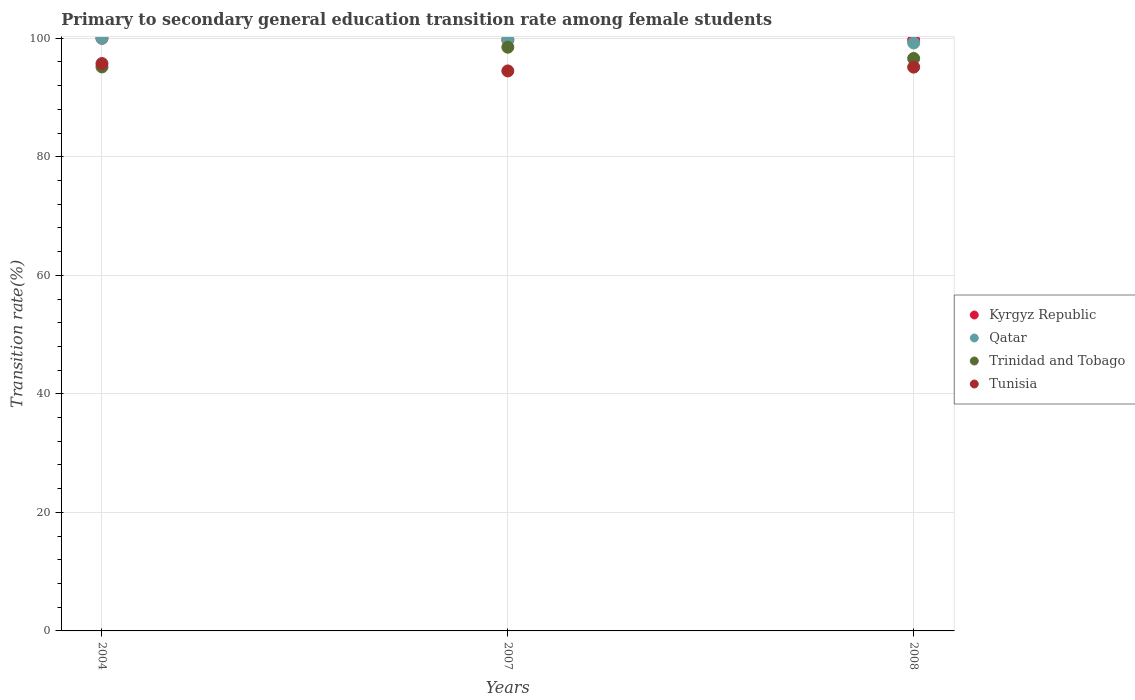How many different coloured dotlines are there?
Your answer should be very brief. 4. What is the transition rate in Kyrgyz Republic in 2008?
Make the answer very short. 99.67. Across all years, what is the minimum transition rate in Trinidad and Tobago?
Keep it short and to the point. 95.15. In which year was the transition rate in Trinidad and Tobago maximum?
Offer a terse response. 2007. In which year was the transition rate in Qatar minimum?
Your response must be concise. 2008. What is the total transition rate in Tunisia in the graph?
Your answer should be compact. 285.33. What is the difference between the transition rate in Kyrgyz Republic in 2007 and that in 2008?
Your response must be concise. 0.04. What is the difference between the transition rate in Kyrgyz Republic in 2004 and the transition rate in Trinidad and Tobago in 2008?
Offer a very short reply. 3.42. What is the average transition rate in Qatar per year?
Ensure brevity in your answer.  99.66. In the year 2007, what is the difference between the transition rate in Trinidad and Tobago and transition rate in Tunisia?
Offer a terse response. 4.01. What is the ratio of the transition rate in Tunisia in 2004 to that in 2007?
Your response must be concise. 1.01. Is the transition rate in Trinidad and Tobago in 2004 less than that in 2007?
Ensure brevity in your answer.  Yes. Is the difference between the transition rate in Trinidad and Tobago in 2004 and 2007 greater than the difference between the transition rate in Tunisia in 2004 and 2007?
Your response must be concise. No. What is the difference between the highest and the second highest transition rate in Tunisia?
Offer a terse response. 0.6. What is the difference between the highest and the lowest transition rate in Kyrgyz Republic?
Your response must be concise. 0.33. Is the sum of the transition rate in Kyrgyz Republic in 2004 and 2007 greater than the maximum transition rate in Trinidad and Tobago across all years?
Ensure brevity in your answer.  Yes. Is it the case that in every year, the sum of the transition rate in Kyrgyz Republic and transition rate in Trinidad and Tobago  is greater than the sum of transition rate in Qatar and transition rate in Tunisia?
Your answer should be compact. Yes. Does the transition rate in Tunisia monotonically increase over the years?
Keep it short and to the point. No. How many years are there in the graph?
Offer a very short reply. 3. What is the difference between two consecutive major ticks on the Y-axis?
Give a very brief answer. 20. Are the values on the major ticks of Y-axis written in scientific E-notation?
Give a very brief answer. No. Where does the legend appear in the graph?
Offer a very short reply. Center right. How many legend labels are there?
Make the answer very short. 4. How are the legend labels stacked?
Ensure brevity in your answer.  Vertical. What is the title of the graph?
Ensure brevity in your answer.  Primary to secondary general education transition rate among female students. What is the label or title of the Y-axis?
Keep it short and to the point. Transition rate(%). What is the Transition rate(%) of Kyrgyz Republic in 2004?
Offer a very short reply. 100. What is the Transition rate(%) of Qatar in 2004?
Your response must be concise. 100. What is the Transition rate(%) of Trinidad and Tobago in 2004?
Provide a short and direct response. 95.15. What is the Transition rate(%) in Tunisia in 2004?
Offer a very short reply. 95.72. What is the Transition rate(%) of Kyrgyz Republic in 2007?
Provide a succinct answer. 99.7. What is the Transition rate(%) in Qatar in 2007?
Your answer should be compact. 99.78. What is the Transition rate(%) of Trinidad and Tobago in 2007?
Offer a very short reply. 98.48. What is the Transition rate(%) in Tunisia in 2007?
Make the answer very short. 94.48. What is the Transition rate(%) of Kyrgyz Republic in 2008?
Offer a terse response. 99.67. What is the Transition rate(%) of Qatar in 2008?
Ensure brevity in your answer.  99.2. What is the Transition rate(%) in Trinidad and Tobago in 2008?
Offer a terse response. 96.58. What is the Transition rate(%) of Tunisia in 2008?
Keep it short and to the point. 95.12. Across all years, what is the maximum Transition rate(%) in Trinidad and Tobago?
Provide a short and direct response. 98.48. Across all years, what is the maximum Transition rate(%) in Tunisia?
Offer a very short reply. 95.72. Across all years, what is the minimum Transition rate(%) in Kyrgyz Republic?
Your response must be concise. 99.67. Across all years, what is the minimum Transition rate(%) in Qatar?
Keep it short and to the point. 99.2. Across all years, what is the minimum Transition rate(%) in Trinidad and Tobago?
Your answer should be compact. 95.15. Across all years, what is the minimum Transition rate(%) in Tunisia?
Offer a very short reply. 94.48. What is the total Transition rate(%) in Kyrgyz Republic in the graph?
Provide a succinct answer. 299.37. What is the total Transition rate(%) in Qatar in the graph?
Keep it short and to the point. 298.98. What is the total Transition rate(%) of Trinidad and Tobago in the graph?
Provide a short and direct response. 290.22. What is the total Transition rate(%) of Tunisia in the graph?
Your response must be concise. 285.33. What is the difference between the Transition rate(%) in Kyrgyz Republic in 2004 and that in 2007?
Give a very brief answer. 0.3. What is the difference between the Transition rate(%) in Qatar in 2004 and that in 2007?
Offer a terse response. 0.22. What is the difference between the Transition rate(%) in Trinidad and Tobago in 2004 and that in 2007?
Your response must be concise. -3.33. What is the difference between the Transition rate(%) of Tunisia in 2004 and that in 2007?
Your answer should be very brief. 1.25. What is the difference between the Transition rate(%) in Kyrgyz Republic in 2004 and that in 2008?
Make the answer very short. 0.33. What is the difference between the Transition rate(%) of Qatar in 2004 and that in 2008?
Offer a very short reply. 0.8. What is the difference between the Transition rate(%) of Trinidad and Tobago in 2004 and that in 2008?
Keep it short and to the point. -1.43. What is the difference between the Transition rate(%) in Tunisia in 2004 and that in 2008?
Give a very brief answer. 0.6. What is the difference between the Transition rate(%) in Kyrgyz Republic in 2007 and that in 2008?
Provide a short and direct response. 0.04. What is the difference between the Transition rate(%) in Qatar in 2007 and that in 2008?
Provide a succinct answer. 0.58. What is the difference between the Transition rate(%) in Tunisia in 2007 and that in 2008?
Your answer should be compact. -0.64. What is the difference between the Transition rate(%) of Kyrgyz Republic in 2004 and the Transition rate(%) of Qatar in 2007?
Your answer should be compact. 0.22. What is the difference between the Transition rate(%) of Kyrgyz Republic in 2004 and the Transition rate(%) of Trinidad and Tobago in 2007?
Make the answer very short. 1.52. What is the difference between the Transition rate(%) of Kyrgyz Republic in 2004 and the Transition rate(%) of Tunisia in 2007?
Your answer should be very brief. 5.52. What is the difference between the Transition rate(%) in Qatar in 2004 and the Transition rate(%) in Trinidad and Tobago in 2007?
Your response must be concise. 1.52. What is the difference between the Transition rate(%) in Qatar in 2004 and the Transition rate(%) in Tunisia in 2007?
Offer a very short reply. 5.52. What is the difference between the Transition rate(%) in Trinidad and Tobago in 2004 and the Transition rate(%) in Tunisia in 2007?
Provide a short and direct response. 0.67. What is the difference between the Transition rate(%) of Kyrgyz Republic in 2004 and the Transition rate(%) of Qatar in 2008?
Your answer should be compact. 0.8. What is the difference between the Transition rate(%) of Kyrgyz Republic in 2004 and the Transition rate(%) of Trinidad and Tobago in 2008?
Ensure brevity in your answer.  3.42. What is the difference between the Transition rate(%) in Kyrgyz Republic in 2004 and the Transition rate(%) in Tunisia in 2008?
Your response must be concise. 4.88. What is the difference between the Transition rate(%) of Qatar in 2004 and the Transition rate(%) of Trinidad and Tobago in 2008?
Keep it short and to the point. 3.42. What is the difference between the Transition rate(%) of Qatar in 2004 and the Transition rate(%) of Tunisia in 2008?
Make the answer very short. 4.88. What is the difference between the Transition rate(%) in Trinidad and Tobago in 2004 and the Transition rate(%) in Tunisia in 2008?
Provide a short and direct response. 0.03. What is the difference between the Transition rate(%) in Kyrgyz Republic in 2007 and the Transition rate(%) in Qatar in 2008?
Offer a terse response. 0.5. What is the difference between the Transition rate(%) in Kyrgyz Republic in 2007 and the Transition rate(%) in Trinidad and Tobago in 2008?
Make the answer very short. 3.12. What is the difference between the Transition rate(%) in Kyrgyz Republic in 2007 and the Transition rate(%) in Tunisia in 2008?
Offer a very short reply. 4.58. What is the difference between the Transition rate(%) of Qatar in 2007 and the Transition rate(%) of Trinidad and Tobago in 2008?
Your answer should be compact. 3.2. What is the difference between the Transition rate(%) of Qatar in 2007 and the Transition rate(%) of Tunisia in 2008?
Offer a terse response. 4.66. What is the difference between the Transition rate(%) in Trinidad and Tobago in 2007 and the Transition rate(%) in Tunisia in 2008?
Provide a short and direct response. 3.36. What is the average Transition rate(%) of Kyrgyz Republic per year?
Ensure brevity in your answer.  99.79. What is the average Transition rate(%) in Qatar per year?
Keep it short and to the point. 99.66. What is the average Transition rate(%) of Trinidad and Tobago per year?
Your response must be concise. 96.74. What is the average Transition rate(%) of Tunisia per year?
Give a very brief answer. 95.11. In the year 2004, what is the difference between the Transition rate(%) in Kyrgyz Republic and Transition rate(%) in Trinidad and Tobago?
Keep it short and to the point. 4.85. In the year 2004, what is the difference between the Transition rate(%) of Kyrgyz Republic and Transition rate(%) of Tunisia?
Offer a very short reply. 4.28. In the year 2004, what is the difference between the Transition rate(%) of Qatar and Transition rate(%) of Trinidad and Tobago?
Your answer should be very brief. 4.85. In the year 2004, what is the difference between the Transition rate(%) in Qatar and Transition rate(%) in Tunisia?
Your answer should be compact. 4.28. In the year 2004, what is the difference between the Transition rate(%) in Trinidad and Tobago and Transition rate(%) in Tunisia?
Give a very brief answer. -0.57. In the year 2007, what is the difference between the Transition rate(%) in Kyrgyz Republic and Transition rate(%) in Qatar?
Your response must be concise. -0.08. In the year 2007, what is the difference between the Transition rate(%) of Kyrgyz Republic and Transition rate(%) of Trinidad and Tobago?
Your answer should be compact. 1.22. In the year 2007, what is the difference between the Transition rate(%) in Kyrgyz Republic and Transition rate(%) in Tunisia?
Provide a succinct answer. 5.22. In the year 2007, what is the difference between the Transition rate(%) in Qatar and Transition rate(%) in Trinidad and Tobago?
Provide a short and direct response. 1.3. In the year 2007, what is the difference between the Transition rate(%) of Qatar and Transition rate(%) of Tunisia?
Make the answer very short. 5.3. In the year 2007, what is the difference between the Transition rate(%) in Trinidad and Tobago and Transition rate(%) in Tunisia?
Offer a terse response. 4.01. In the year 2008, what is the difference between the Transition rate(%) of Kyrgyz Republic and Transition rate(%) of Qatar?
Your answer should be very brief. 0.47. In the year 2008, what is the difference between the Transition rate(%) of Kyrgyz Republic and Transition rate(%) of Trinidad and Tobago?
Ensure brevity in your answer.  3.08. In the year 2008, what is the difference between the Transition rate(%) of Kyrgyz Republic and Transition rate(%) of Tunisia?
Make the answer very short. 4.54. In the year 2008, what is the difference between the Transition rate(%) of Qatar and Transition rate(%) of Trinidad and Tobago?
Ensure brevity in your answer.  2.61. In the year 2008, what is the difference between the Transition rate(%) of Qatar and Transition rate(%) of Tunisia?
Keep it short and to the point. 4.07. In the year 2008, what is the difference between the Transition rate(%) of Trinidad and Tobago and Transition rate(%) of Tunisia?
Offer a terse response. 1.46. What is the ratio of the Transition rate(%) of Kyrgyz Republic in 2004 to that in 2007?
Keep it short and to the point. 1. What is the ratio of the Transition rate(%) of Qatar in 2004 to that in 2007?
Make the answer very short. 1. What is the ratio of the Transition rate(%) in Trinidad and Tobago in 2004 to that in 2007?
Provide a short and direct response. 0.97. What is the ratio of the Transition rate(%) of Tunisia in 2004 to that in 2007?
Make the answer very short. 1.01. What is the ratio of the Transition rate(%) of Kyrgyz Republic in 2004 to that in 2008?
Provide a succinct answer. 1. What is the ratio of the Transition rate(%) of Qatar in 2004 to that in 2008?
Your response must be concise. 1.01. What is the ratio of the Transition rate(%) in Trinidad and Tobago in 2004 to that in 2008?
Your answer should be compact. 0.99. What is the ratio of the Transition rate(%) of Qatar in 2007 to that in 2008?
Ensure brevity in your answer.  1.01. What is the ratio of the Transition rate(%) in Trinidad and Tobago in 2007 to that in 2008?
Offer a terse response. 1.02. What is the ratio of the Transition rate(%) of Tunisia in 2007 to that in 2008?
Offer a terse response. 0.99. What is the difference between the highest and the second highest Transition rate(%) of Kyrgyz Republic?
Keep it short and to the point. 0.3. What is the difference between the highest and the second highest Transition rate(%) of Qatar?
Ensure brevity in your answer.  0.22. What is the difference between the highest and the second highest Transition rate(%) in Trinidad and Tobago?
Your answer should be very brief. 1.9. What is the difference between the highest and the second highest Transition rate(%) in Tunisia?
Provide a succinct answer. 0.6. What is the difference between the highest and the lowest Transition rate(%) in Kyrgyz Republic?
Your answer should be compact. 0.33. What is the difference between the highest and the lowest Transition rate(%) of Qatar?
Provide a succinct answer. 0.8. What is the difference between the highest and the lowest Transition rate(%) in Trinidad and Tobago?
Your response must be concise. 3.33. What is the difference between the highest and the lowest Transition rate(%) in Tunisia?
Your response must be concise. 1.25. 